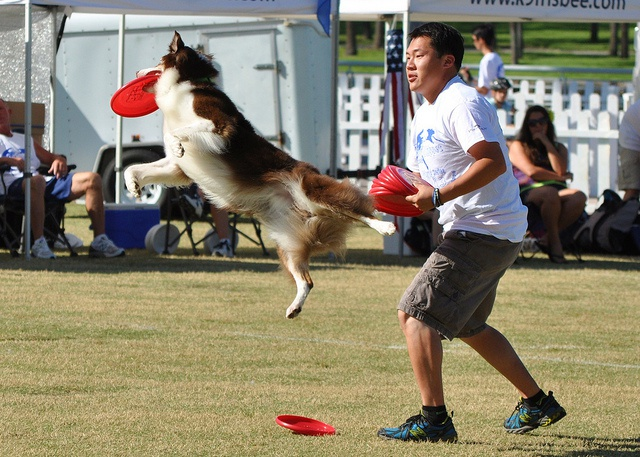Describe the objects in this image and their specific colors. I can see people in lightgray, black, white, maroon, and darkgray tones, truck in lightgray, gray, and darkgray tones, dog in lightgray, black, ivory, and maroon tones, people in lightgray, black, maroon, gray, and darkgray tones, and people in lightgray, black, maroon, and tan tones in this image. 